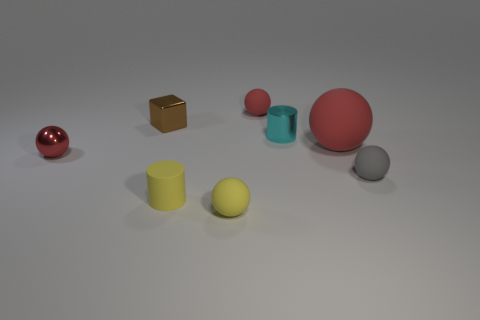Add 1 red metallic spheres. How many objects exist? 9 Subtract all small gray rubber spheres. How many spheres are left? 4 Subtract all gray cylinders. How many red spheres are left? 3 Subtract 1 cylinders. How many cylinders are left? 1 Subtract all yellow spheres. How many spheres are left? 4 Subtract all red cylinders. Subtract all purple spheres. How many cylinders are left? 2 Subtract all large brown objects. Subtract all tiny cyan objects. How many objects are left? 7 Add 4 small rubber spheres. How many small rubber spheres are left? 7 Add 4 rubber cylinders. How many rubber cylinders exist? 5 Subtract 1 gray balls. How many objects are left? 7 